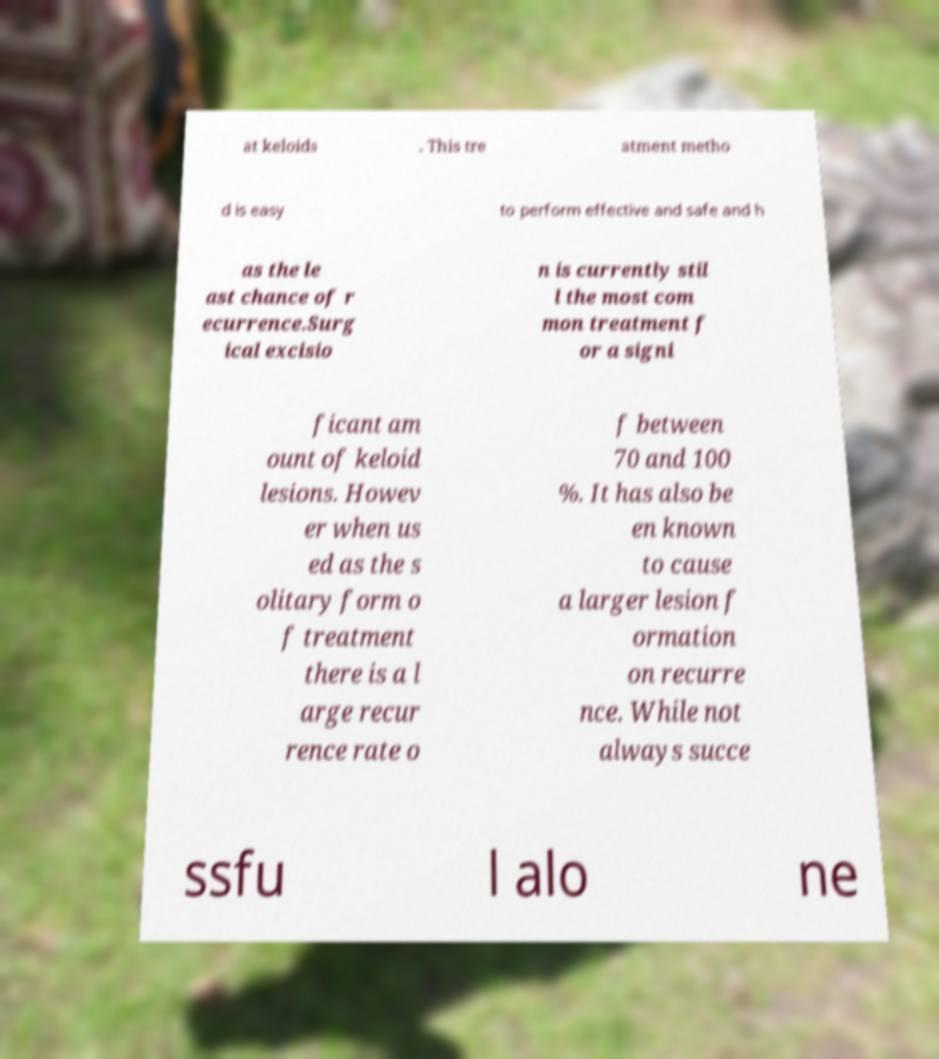Can you read and provide the text displayed in the image?This photo seems to have some interesting text. Can you extract and type it out for me? at keloids . This tre atment metho d is easy to perform effective and safe and h as the le ast chance of r ecurrence.Surg ical excisio n is currently stil l the most com mon treatment f or a signi ficant am ount of keloid lesions. Howev er when us ed as the s olitary form o f treatment there is a l arge recur rence rate o f between 70 and 100 %. It has also be en known to cause a larger lesion f ormation on recurre nce. While not always succe ssfu l alo ne 